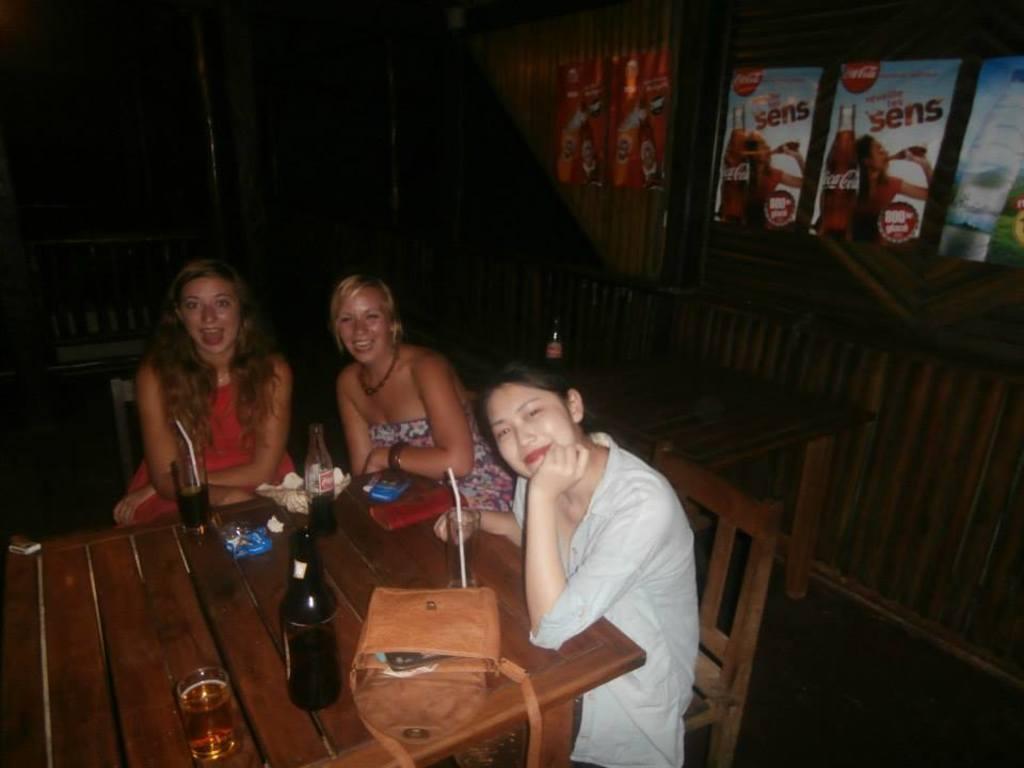Could you give a brief overview of what you see in this image? In this image there is a table on the table there are bottles, glasses, bag, pouch. There are chairs around the table. On the chairs three ladies are sitting. They all are smiling. In the background there are some posters on the wall and another table there is a bottle on it. 